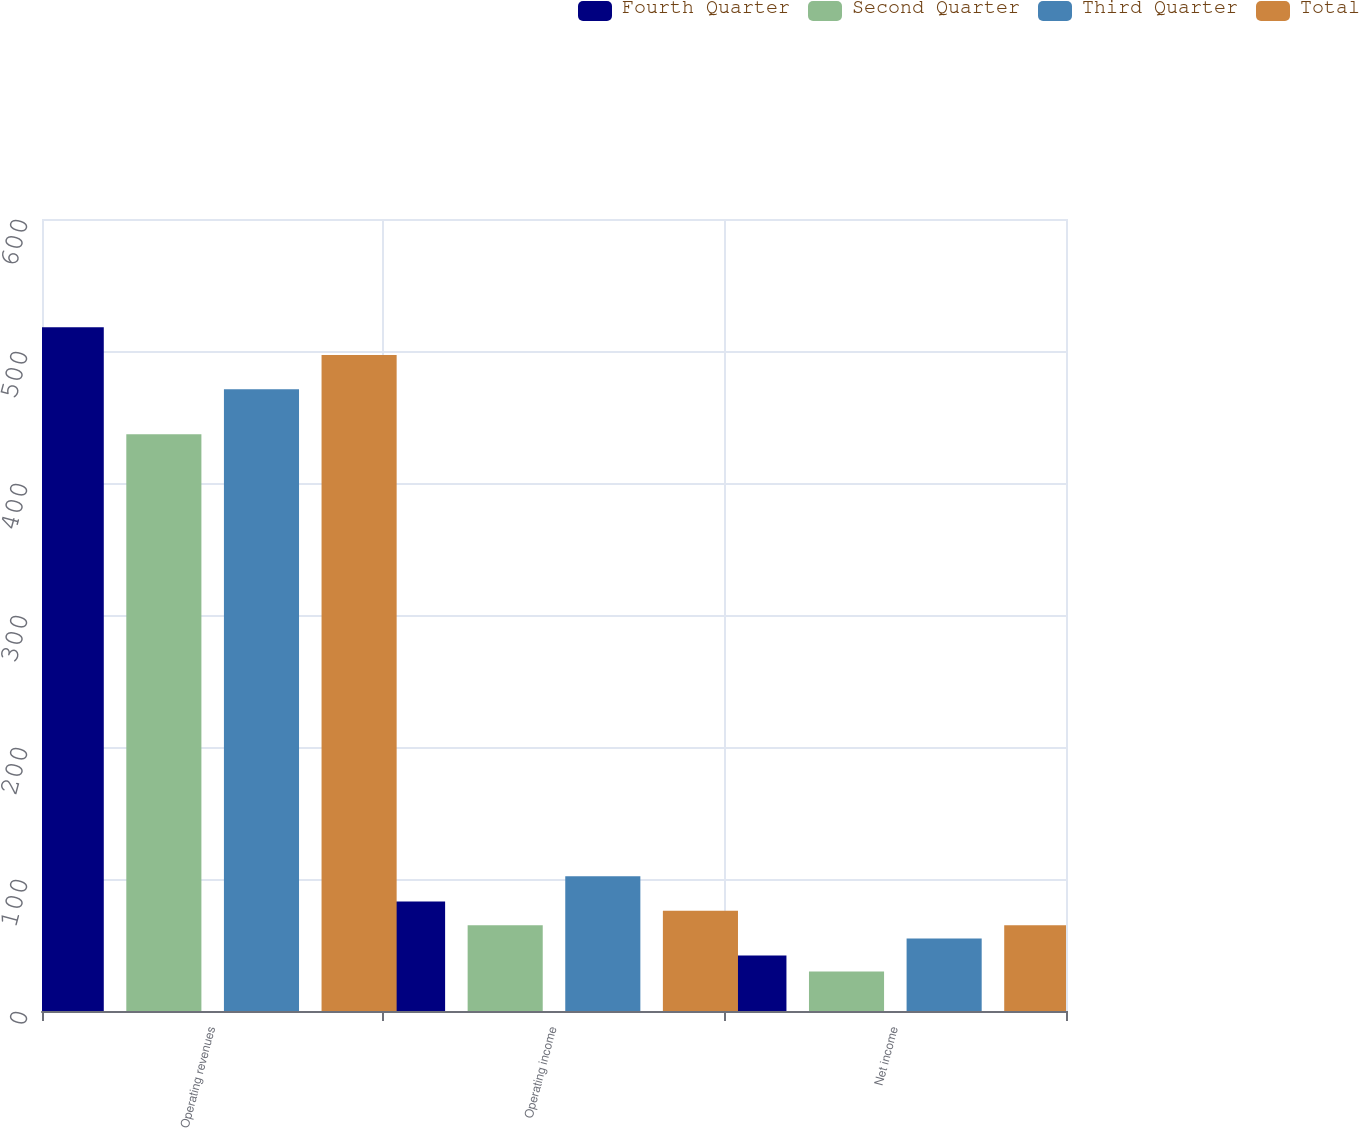Convert chart. <chart><loc_0><loc_0><loc_500><loc_500><stacked_bar_chart><ecel><fcel>Operating revenues<fcel>Operating income<fcel>Net income<nl><fcel>Fourth Quarter<fcel>518<fcel>83<fcel>42<nl><fcel>Second Quarter<fcel>437<fcel>65<fcel>30<nl><fcel>Third Quarter<fcel>471<fcel>102<fcel>55<nl><fcel>Total<fcel>497<fcel>76<fcel>65<nl></chart> 